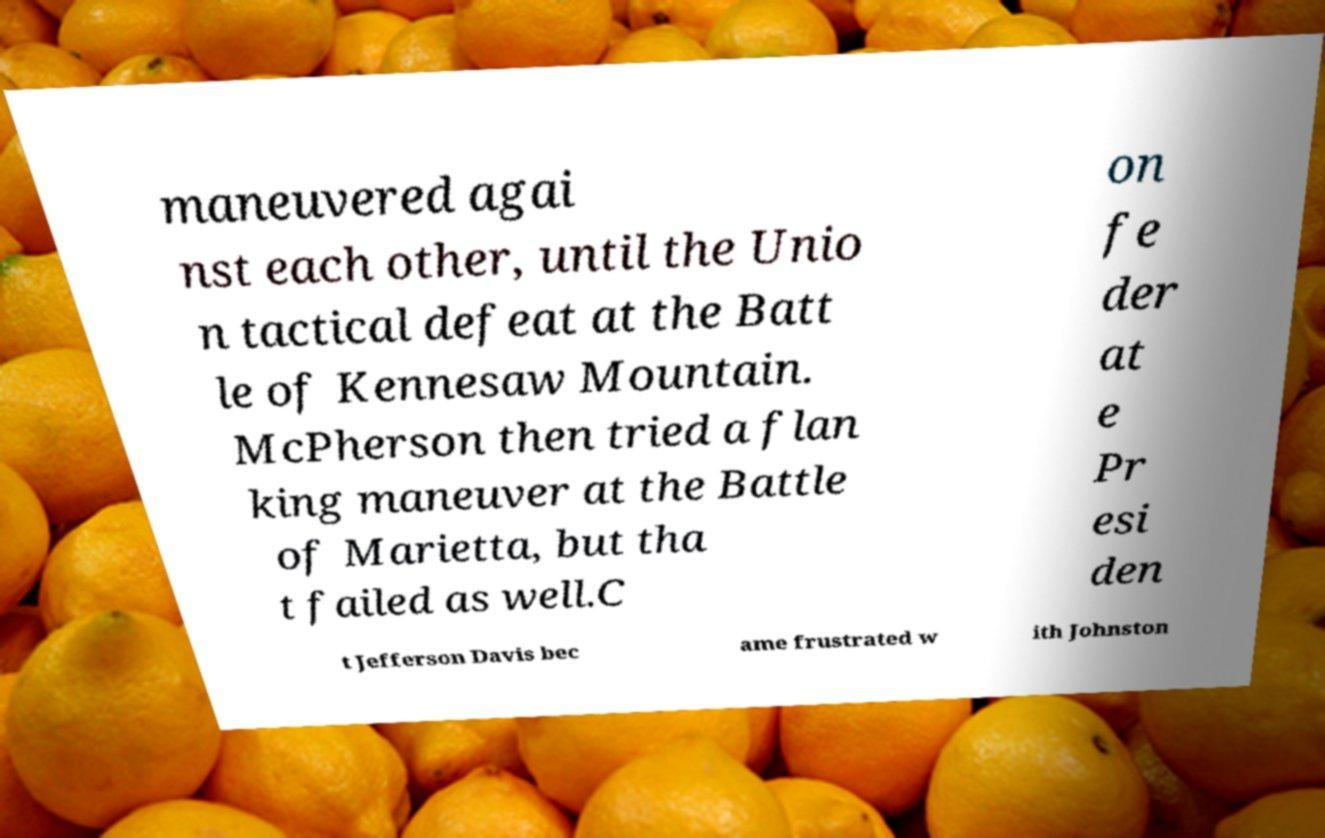Could you extract and type out the text from this image? maneuvered agai nst each other, until the Unio n tactical defeat at the Batt le of Kennesaw Mountain. McPherson then tried a flan king maneuver at the Battle of Marietta, but tha t failed as well.C on fe der at e Pr esi den t Jefferson Davis bec ame frustrated w ith Johnston 